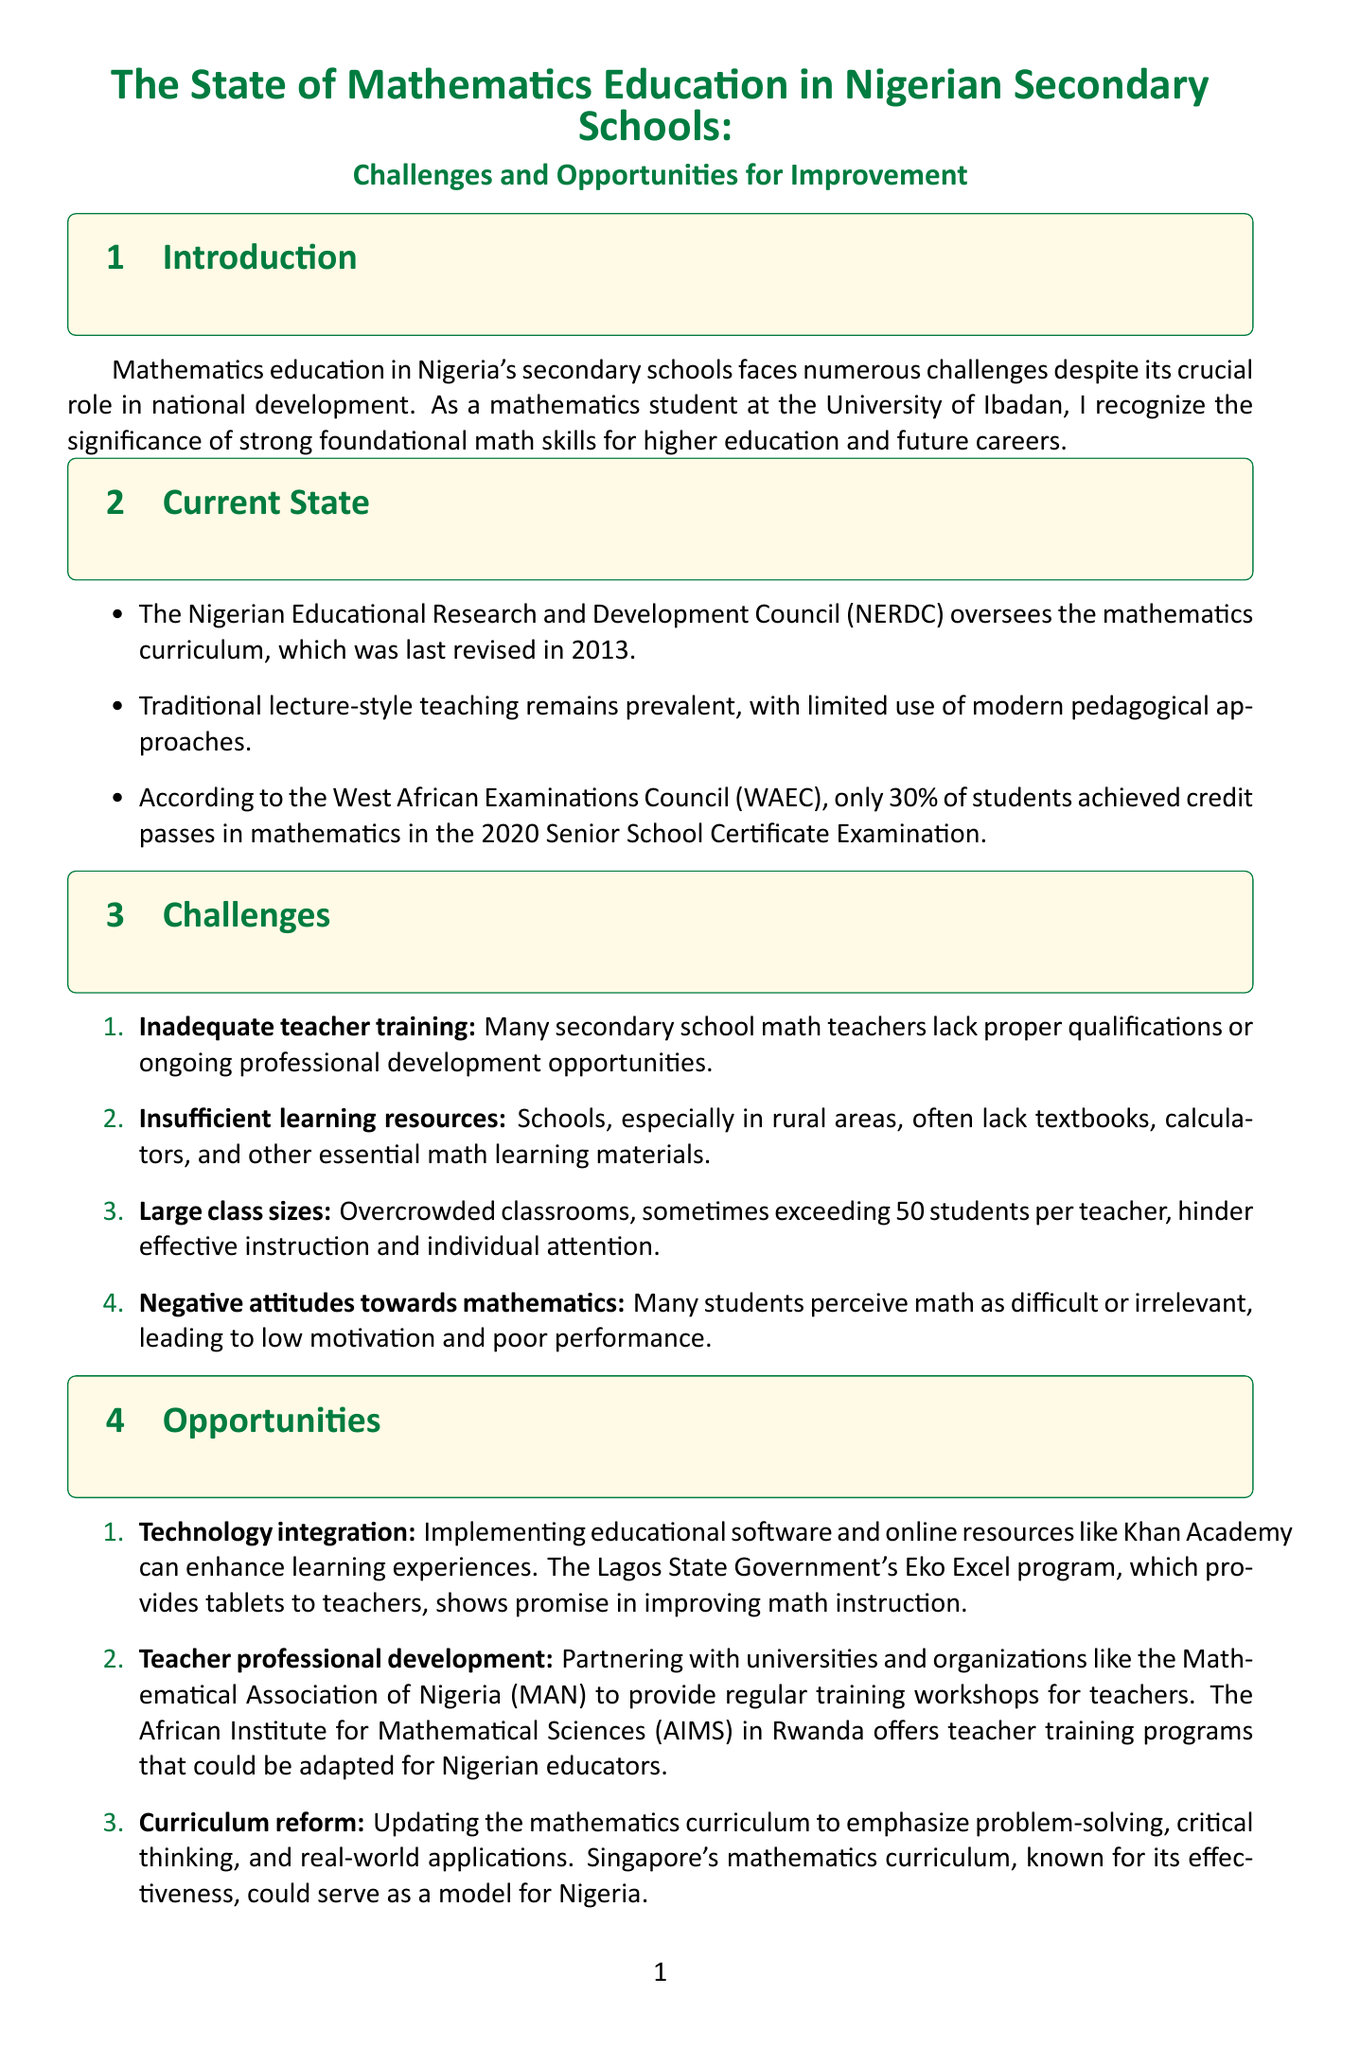what is the title of the report? The title of the report is provided at the beginning of the document, summarizing its focus.
Answer: The State of Mathematics Education in Nigerian Secondary Schools: Challenges and Opportunities for Improvement what percentage of students achieved credit passes in mathematics in the 2020 Senior School Certificate Examination? The document mentions this statistic in the current state section, highlighting the performance of students in mathematics.
Answer: 30% who oversees the mathematics curriculum in Nigeria? The document specifies the organization responsible for the mathematics curriculum within the Nigerian education system.
Answer: Nigerian Educational Research and Development Council (NERDC) what is one of the challenges related to teacher qualifications? The report identifies issues regarding teacher training in the challenges section, specifically regarding their qualifications.
Answer: Inadequate teacher training name one opportunity for improving mathematics education mentioned in the report. The document outlines several opportunities for enhancement in mathematics education, one of which is focused on technology.
Answer: Technology integration how many challenges are listed in the report? The number of challenges is presented in an enumerated list within the challenges section of the document.
Answer: Four which state government program is mentioned as an example of technology integration in mathematics education? The report provides an example of a program aiming to enhance math instruction through technology in the opportunities section.
Answer: Eko Excel program what is the overall call to action in the conclusion? The conclusion summarizes the desired action or advocacy for future mathematicians and educators to improve the situation.
Answer: Advocate for these improvements 